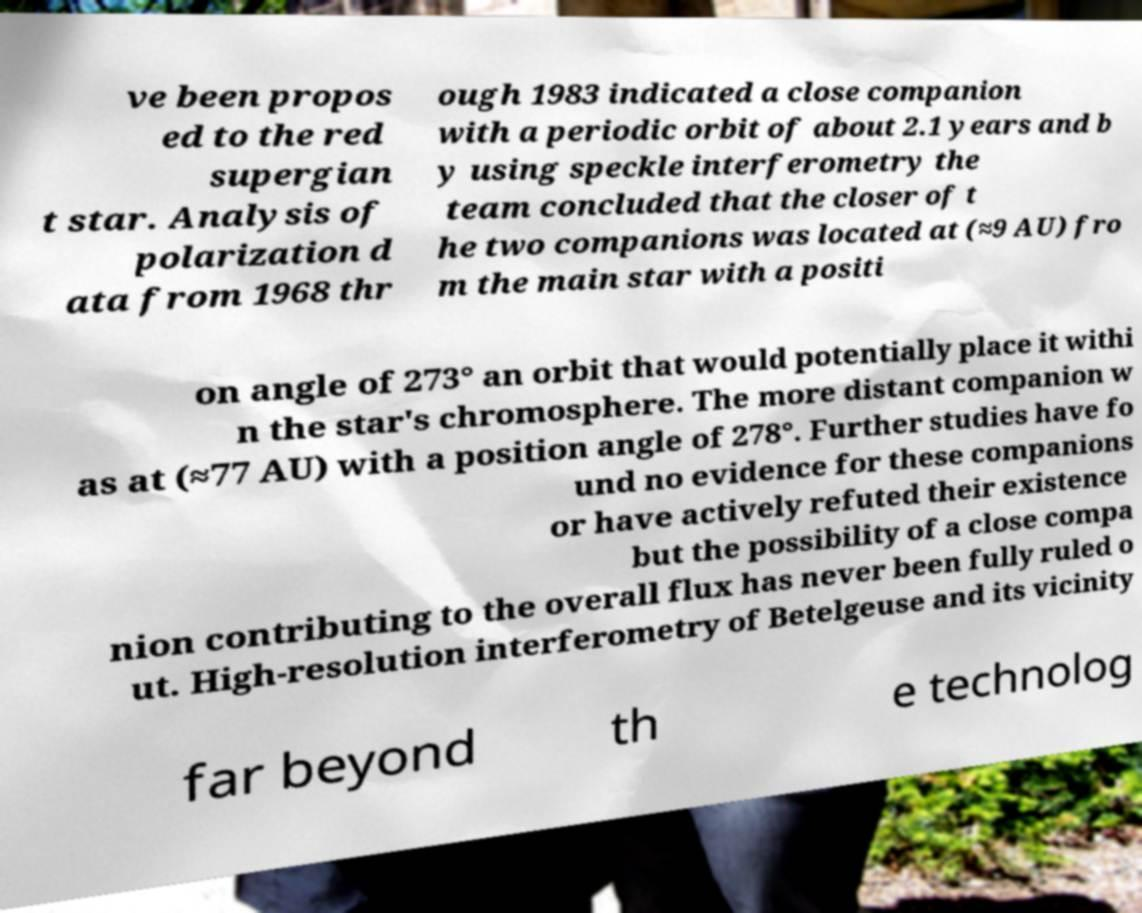Please identify and transcribe the text found in this image. ve been propos ed to the red supergian t star. Analysis of polarization d ata from 1968 thr ough 1983 indicated a close companion with a periodic orbit of about 2.1 years and b y using speckle interferometry the team concluded that the closer of t he two companions was located at (≈9 AU) fro m the main star with a positi on angle of 273° an orbit that would potentially place it withi n the star's chromosphere. The more distant companion w as at (≈77 AU) with a position angle of 278°. Further studies have fo und no evidence for these companions or have actively refuted their existence but the possibility of a close compa nion contributing to the overall flux has never been fully ruled o ut. High-resolution interferometry of Betelgeuse and its vicinity far beyond th e technolog 